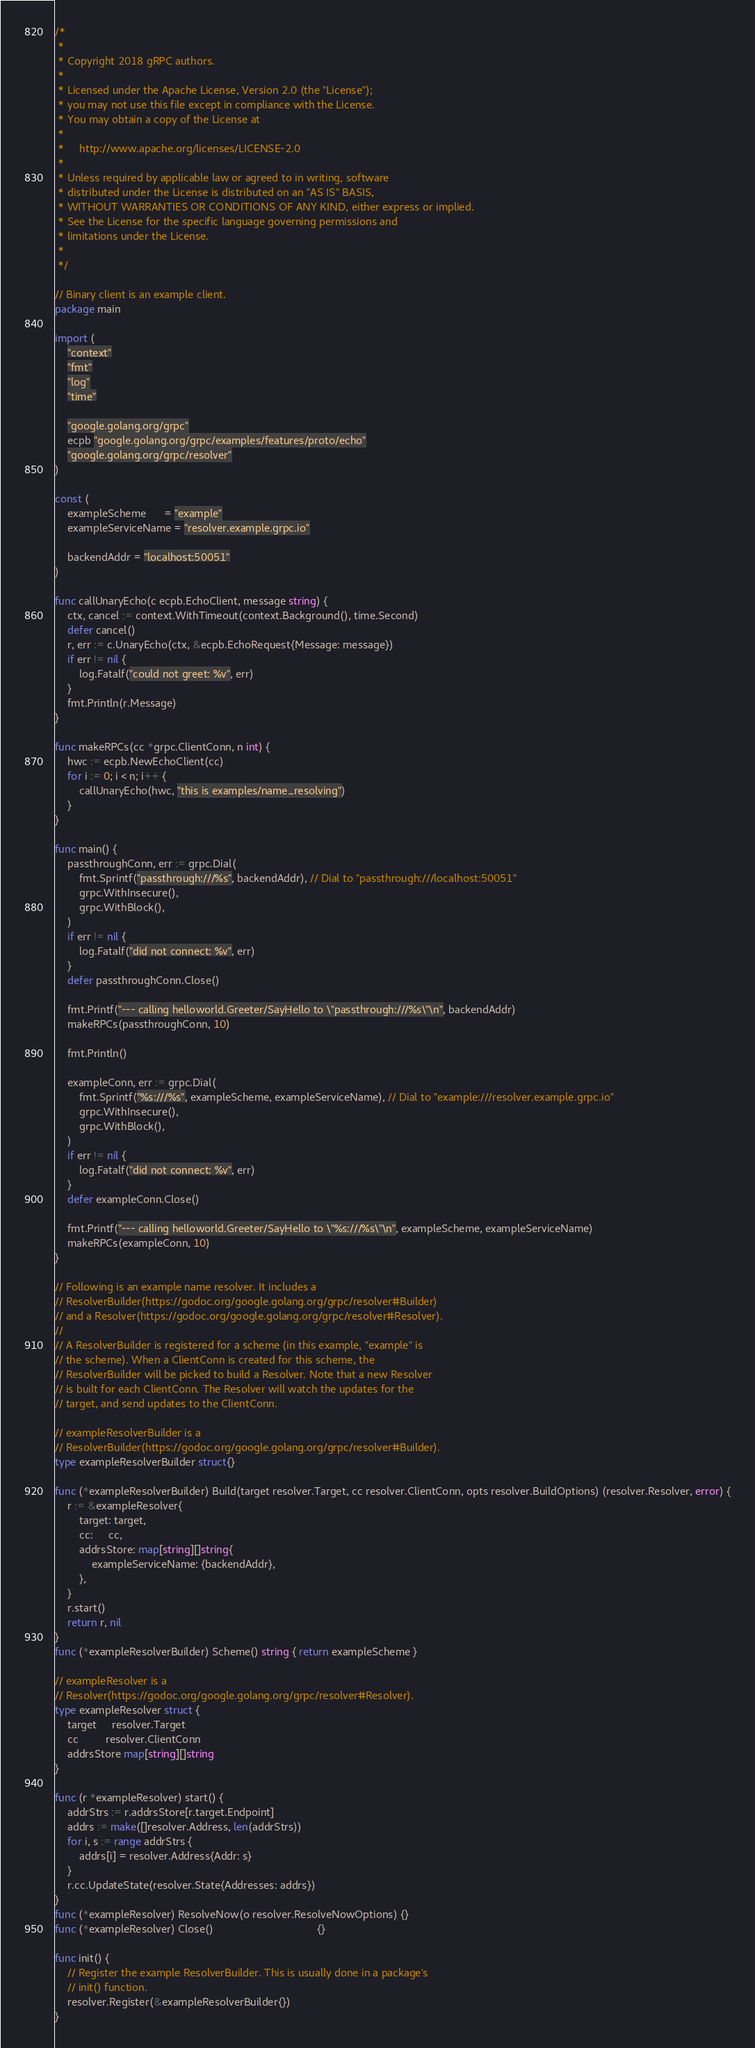<code> <loc_0><loc_0><loc_500><loc_500><_Go_>/*
 *
 * Copyright 2018 gRPC authors.
 *
 * Licensed under the Apache License, Version 2.0 (the "License");
 * you may not use this file except in compliance with the License.
 * You may obtain a copy of the License at
 *
 *     http://www.apache.org/licenses/LICENSE-2.0
 *
 * Unless required by applicable law or agreed to in writing, software
 * distributed under the License is distributed on an "AS IS" BASIS,
 * WITHOUT WARRANTIES OR CONDITIONS OF ANY KIND, either express or implied.
 * See the License for the specific language governing permissions and
 * limitations under the License.
 *
 */

// Binary client is an example client.
package main

import (
	"context"
	"fmt"
	"log"
	"time"

	"google.golang.org/grpc"
	ecpb "google.golang.org/grpc/examples/features/proto/echo"
	"google.golang.org/grpc/resolver"
)

const (
	exampleScheme      = "example"
	exampleServiceName = "resolver.example.grpc.io"

	backendAddr = "localhost:50051"
)

func callUnaryEcho(c ecpb.EchoClient, message string) {
	ctx, cancel := context.WithTimeout(context.Background(), time.Second)
	defer cancel()
	r, err := c.UnaryEcho(ctx, &ecpb.EchoRequest{Message: message})
	if err != nil {
		log.Fatalf("could not greet: %v", err)
	}
	fmt.Println(r.Message)
}

func makeRPCs(cc *grpc.ClientConn, n int) {
	hwc := ecpb.NewEchoClient(cc)
	for i := 0; i < n; i++ {
		callUnaryEcho(hwc, "this is examples/name_resolving")
	}
}

func main() {
	passthroughConn, err := grpc.Dial(
		fmt.Sprintf("passthrough:///%s", backendAddr), // Dial to "passthrough:///localhost:50051"
		grpc.WithInsecure(),
		grpc.WithBlock(),
	)
	if err != nil {
		log.Fatalf("did not connect: %v", err)
	}
	defer passthroughConn.Close()

	fmt.Printf("--- calling helloworld.Greeter/SayHello to \"passthrough:///%s\"\n", backendAddr)
	makeRPCs(passthroughConn, 10)

	fmt.Println()

	exampleConn, err := grpc.Dial(
		fmt.Sprintf("%s:///%s", exampleScheme, exampleServiceName), // Dial to "example:///resolver.example.grpc.io"
		grpc.WithInsecure(),
		grpc.WithBlock(),
	)
	if err != nil {
		log.Fatalf("did not connect: %v", err)
	}
	defer exampleConn.Close()

	fmt.Printf("--- calling helloworld.Greeter/SayHello to \"%s:///%s\"\n", exampleScheme, exampleServiceName)
	makeRPCs(exampleConn, 10)
}

// Following is an example name resolver. It includes a
// ResolverBuilder(https://godoc.org/google.golang.org/grpc/resolver#Builder)
// and a Resolver(https://godoc.org/google.golang.org/grpc/resolver#Resolver).
//
// A ResolverBuilder is registered for a scheme (in this example, "example" is
// the scheme). When a ClientConn is created for this scheme, the
// ResolverBuilder will be picked to build a Resolver. Note that a new Resolver
// is built for each ClientConn. The Resolver will watch the updates for the
// target, and send updates to the ClientConn.

// exampleResolverBuilder is a
// ResolverBuilder(https://godoc.org/google.golang.org/grpc/resolver#Builder).
type exampleResolverBuilder struct{}

func (*exampleResolverBuilder) Build(target resolver.Target, cc resolver.ClientConn, opts resolver.BuildOptions) (resolver.Resolver, error) {
	r := &exampleResolver{
		target: target,
		cc:     cc,
		addrsStore: map[string][]string{
			exampleServiceName: {backendAddr},
		},
	}
	r.start()
	return r, nil
}
func (*exampleResolverBuilder) Scheme() string { return exampleScheme }

// exampleResolver is a
// Resolver(https://godoc.org/google.golang.org/grpc/resolver#Resolver).
type exampleResolver struct {
	target     resolver.Target
	cc         resolver.ClientConn
	addrsStore map[string][]string
}

func (r *exampleResolver) start() {
	addrStrs := r.addrsStore[r.target.Endpoint]
	addrs := make([]resolver.Address, len(addrStrs))
	for i, s := range addrStrs {
		addrs[i] = resolver.Address{Addr: s}
	}
	r.cc.UpdateState(resolver.State{Addresses: addrs})
}
func (*exampleResolver) ResolveNow(o resolver.ResolveNowOptions) {}
func (*exampleResolver) Close()                                  {}

func init() {
	// Register the example ResolverBuilder. This is usually done in a package's
	// init() function.
	resolver.Register(&exampleResolverBuilder{})
}
</code> 